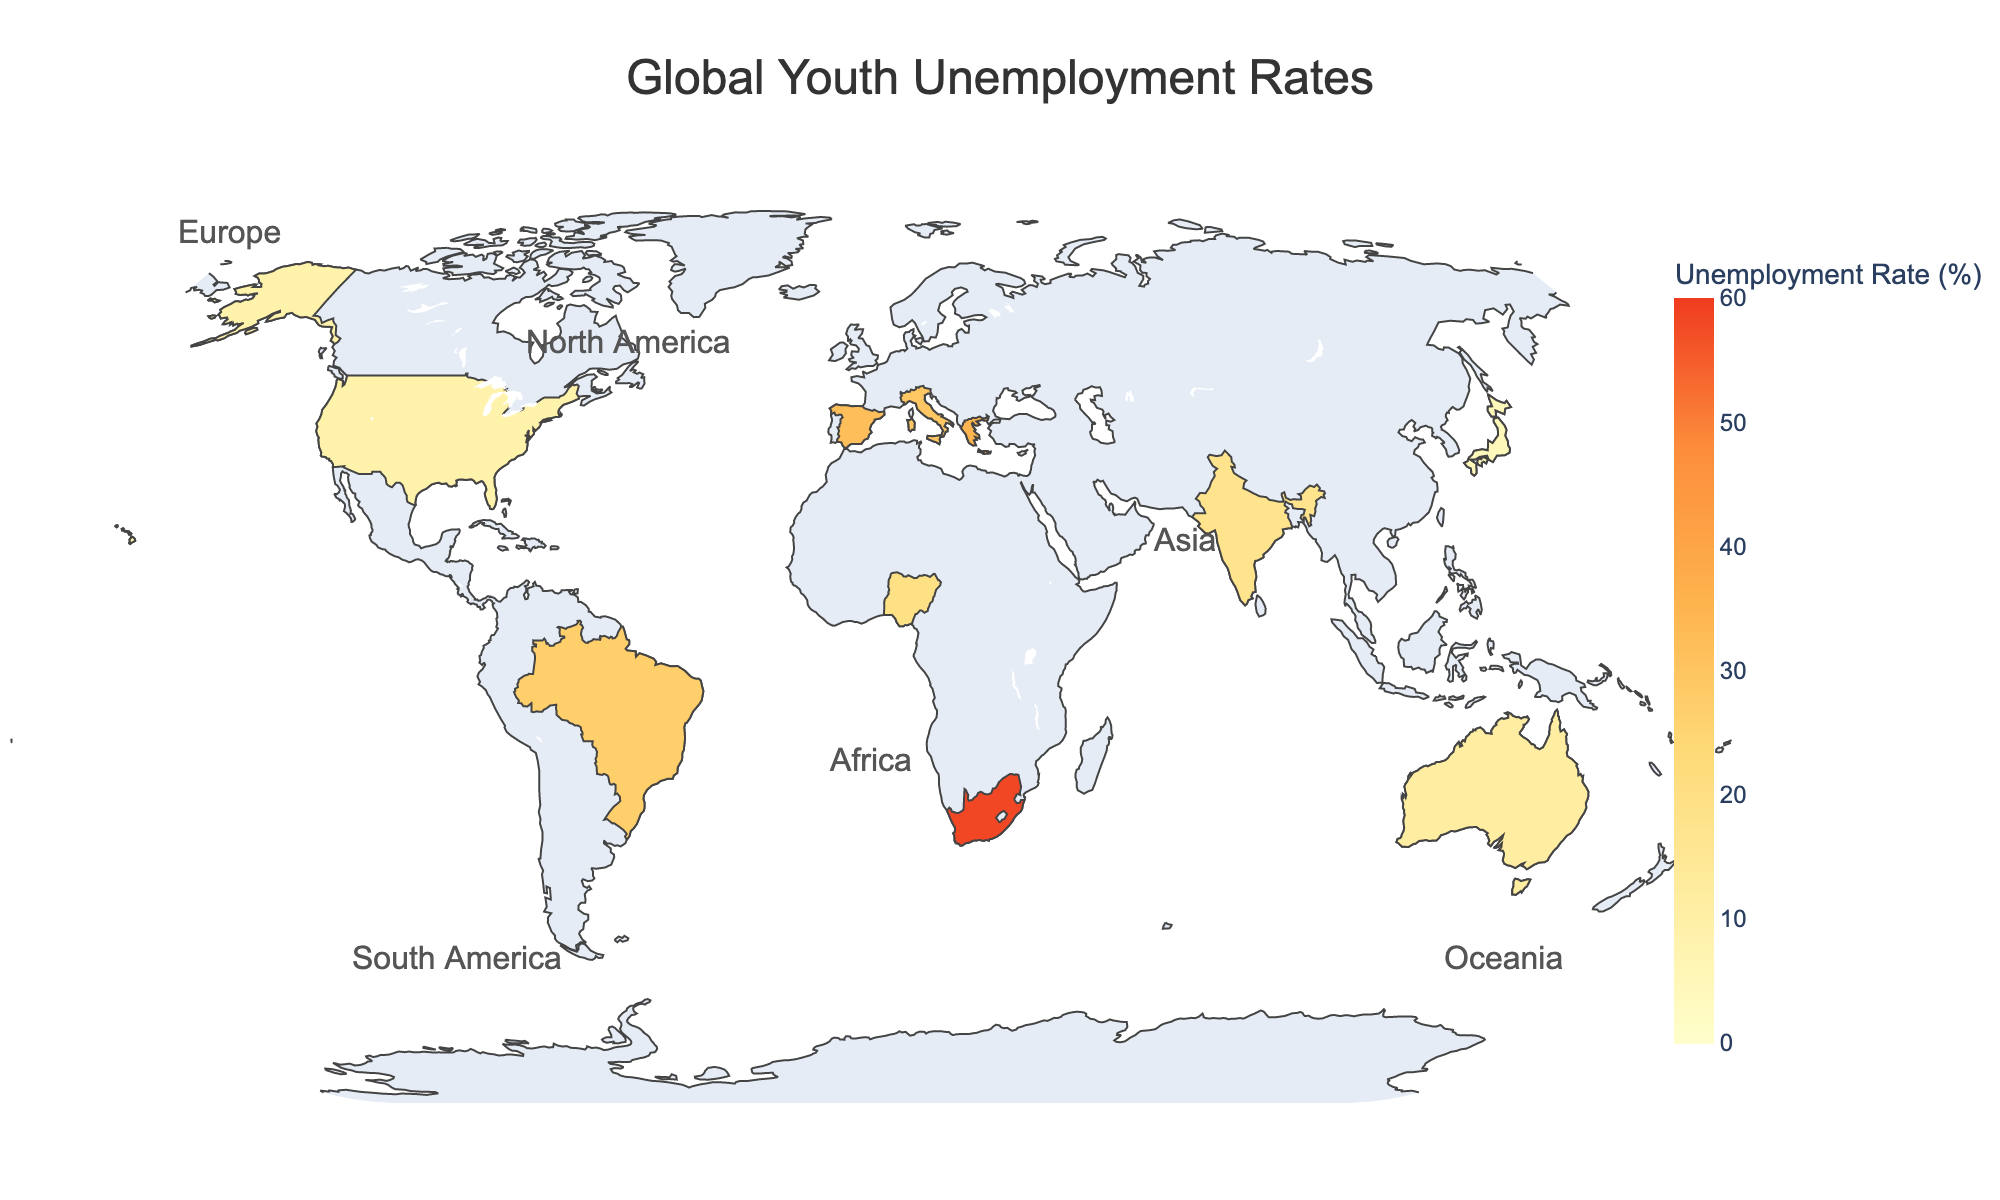Which country has the highest total youth unemployment rate? The country with the highest total youth unemployment rate can be found by looking at the color intensity and the data values. South Africa has the highest rate of 58.2%.
Answer: South Africa What is the difference between the female and male youth unemployment rates in Greece? To find the difference, subtract the male youth unemployment rate from the female youth unemployment rate in Greece: 39.7% - 31.5% = 8.2%.
Answer: 8.2% How does the youth unemployment rate in Japan compare to that in Australia? By comparing the values on the plot, we see that Japan's total youth unemployment rate is lower (4.6%) than Australia's (11.8%).
Answer: Japan has a lower rate What is the average youth unemployment rate for Europe (Spain, Greece, Italy)? To calculate the average, add the total youth unemployment rates of Spain, Greece, and Italy, then divide by the number of countries: (32.1% + 35.2% + 29.4%) / 3 = 32.23%.
Answer: 32.23% In which region is the youth unemployment rate more pronounced between genders (i.e., larger difference between female and male rates)? Calculate the differences for each country and compare. South Africa has the largest difference (61.5% - 55.1% = 6.4%).
Answer: South Africa Which country has the lowest female youth unemployment rate? The country with the lowest female youth unemployment rate can be found by comparing values; Japan has the lowest rate at 4.2%.
Answer: Japan Between India and the United States, which country has a higher male youth unemployment rate? By comparing the values, India has a male youth unemployment rate of 16.2% and the United States has 9.9%. India is higher.
Answer: India What is the combined total youth unemployment rate for Brazil and Nigeria? Sum the total youth unemployment rates for Brazil and Nigeria: 27.1% + 19.8% = 46.9%.
Answer: 46.9% How does the youth unemployment rate in Europe compare to that in Africa? Sum the total youth unemployment rates for countries in Europe and Africa and then compare average rates. Europe: (32.1% + 35.2% + 29.4%) / 3 = 32.23%. Africa: (58.2% + 19.8%) / 2 = 39%. Africa has a higher average rate.
Answer: Africa has a higher average rate Which region has the country with the lowest overall youth unemployment rate? By visual inspection, Japan (Asia) has the lowest overall youth unemployment rate at 4.6%.
Answer: Asia 